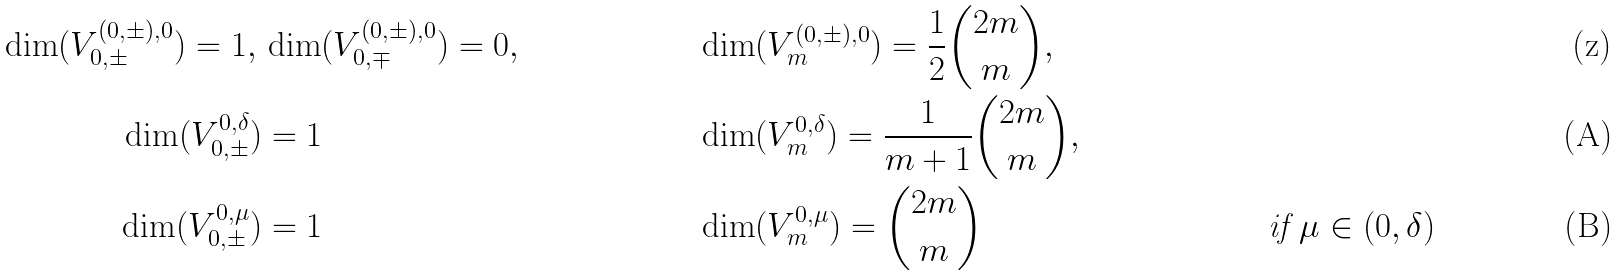Convert formula to latex. <formula><loc_0><loc_0><loc_500><loc_500>\dim ( V _ { 0 , \pm } ^ { ( 0 , \pm ) , 0 } ) = 1 , \, & \dim ( V _ { 0 , \mp } ^ { ( 0 , \pm ) , 0 } ) = 0 , & & \dim ( V _ { m } ^ { ( 0 , \pm ) , 0 } ) = \frac { 1 } { 2 } \binom { 2 m } { m } , \\ \dim ( V _ { 0 , \pm } ^ { 0 , \delta } ) & = 1 & & \dim ( V _ { m } ^ { 0 , \delta } ) = \frac { 1 } { m + 1 } \binom { 2 m } { m } , \\ \dim ( V _ { 0 , \pm } ^ { 0 , \mu } ) & = 1 & & \dim ( V _ { m } ^ { 0 , \mu } ) = \binom { 2 m } { m } & \text { if } \mu \in ( 0 , \delta )</formula> 